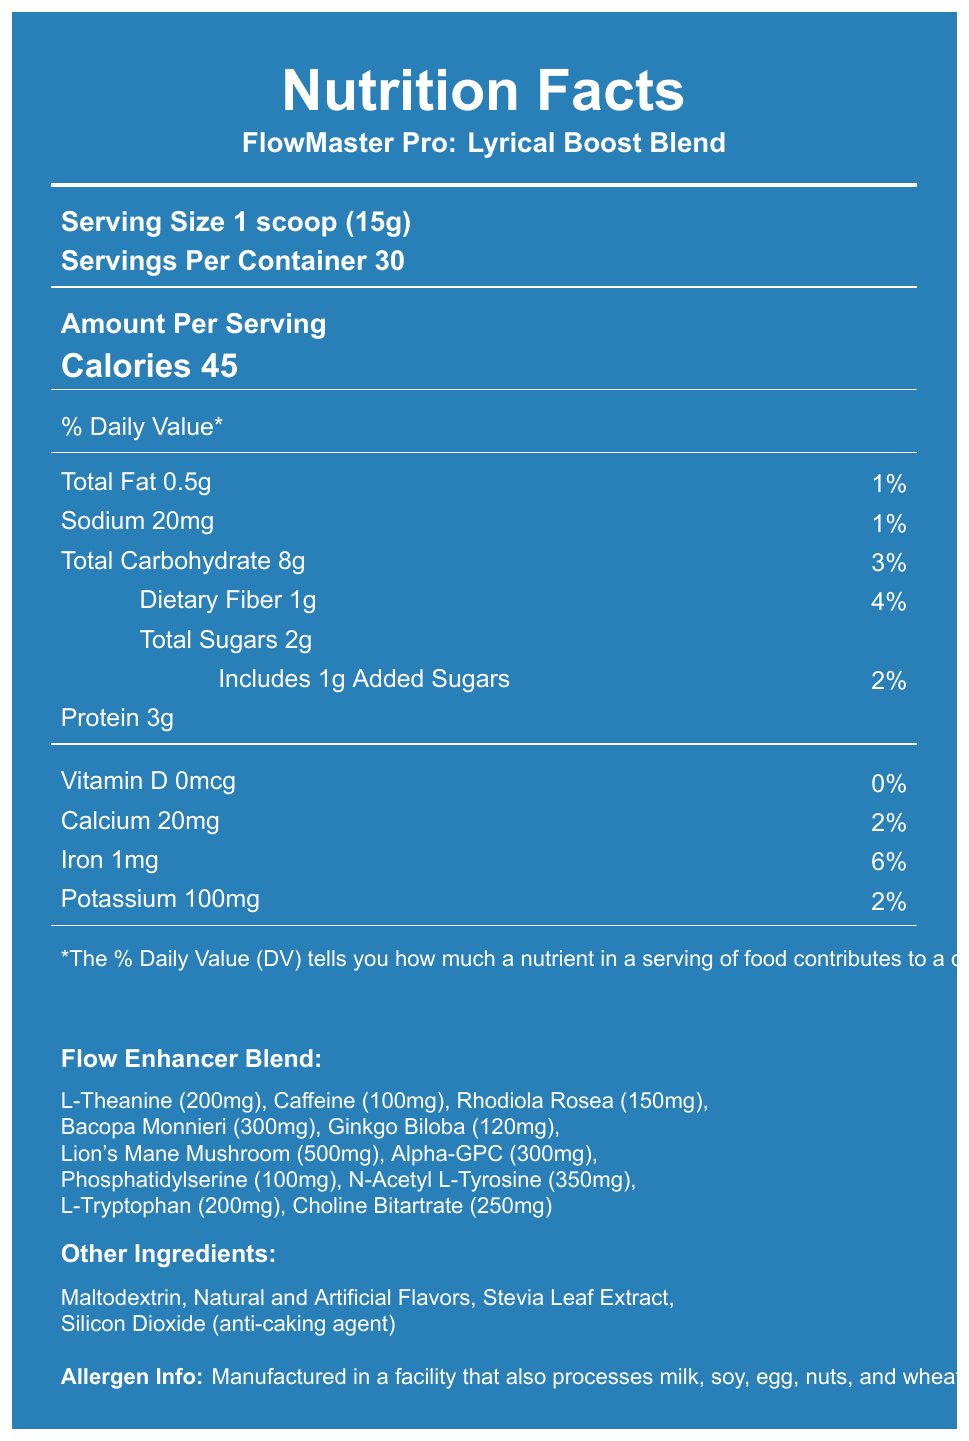what is the serving size of FlowMaster Pro: Lyrical Boost Blend? The serving size is specifically mentioned as "1 scoop (15g)" in the document.
Answer: 1 scoop (15g) how many servings are there per container? The document clearly states that there are "30 servings per container."
Answer: 30 what are the total calories per serving? The "Calories 45" information is given under the "Amount Per Serving" section.
Answer: 45 how much protein does one serving provide? Under the nutrient details, it is mentioned that there is "Protein 3g" per serving.
Answer: 3g which ingredient comes first in the Flow Enhancer Blend? The first ingredient listed in the Flow Enhancer Blend is "L-Theanine (200mg)."
Answer: L-Theanine (200mg) what is the percentage of the daily value for iron? A. 2% B. 4% C. 6% The document indicates that iron contributes "6%" of the daily value.
Answer: C how much caffeine is in each serving of the blend? A. 50mg B. 100mg C. 200mg The amount of caffeine per serving is "100mg" as listed in the Flow Enhancer Blend.
Answer: B are there any added sugars in this supplement? The document states "Includes 1g Added Sugars" indicating the presence of added sugars.
Answer: Yes is the Lyrical Boost Blend recommended for children? One of the warnings states explicitly that the product is "Not recommended for children."
Answer: No what are some of the cognitive-enhancing ingredients in this blend? These ingredients are listed under the "Flow Enhancer Blend" section with their specific amounts.
Answer: L-Theanine, Caffeine, Rhodiola Rosea, Bacopa Monnieri, Ginkgo Biloba, Lion's Mane Mushroom, Alpha-GPC, Phosphatidylserine, N-Acetyl L-Tyrosine, L-Tryptophan, Choline Bitartrate summarize the main idea of the document. This summary encapsulates all the significant sections of the document, giving a complete overview.
Answer: The document is a Nutrition Facts Label for the "FlowMaster Pro: Lyrical Boost Blend" supplement powder, designed to enhance cognitive function and creativity. It details the serving size, number of servings per container, caloric content, macronutrients, vitamins, minerals, proprietary blend components, other ingredients, allergen information, usage directions, warnings, manufacturer details, and the website. what is the address of the manufacturer? The manufacturer's address is stated as "123 Beat Street, Rhythm City, CA 90210."
Answer: 123 Beat Street, Rhythm City, CA 90210 how much vitamin B12 is included in each serving? The amount of vitamin B12 per serving is "6mcg" as noted in the nutrient details.
Answer: 6mcg does this supplement contain beta-alanine? The document does not mention beta-alanine directly; thus, this cannot be determined based on the provided information.
Answer: Not enough information 